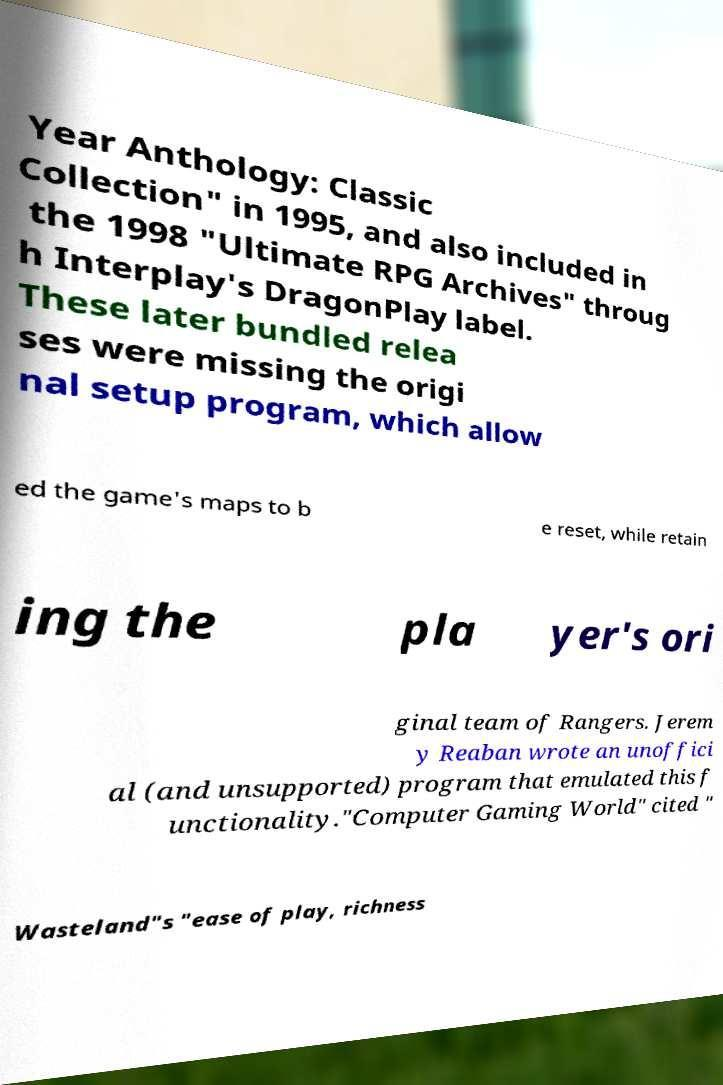Could you assist in decoding the text presented in this image and type it out clearly? Year Anthology: Classic Collection" in 1995, and also included in the 1998 "Ultimate RPG Archives" throug h Interplay's DragonPlay label. These later bundled relea ses were missing the origi nal setup program, which allow ed the game's maps to b e reset, while retain ing the pla yer's ori ginal team of Rangers. Jerem y Reaban wrote an unoffici al (and unsupported) program that emulated this f unctionality."Computer Gaming World" cited " Wasteland"s "ease of play, richness 